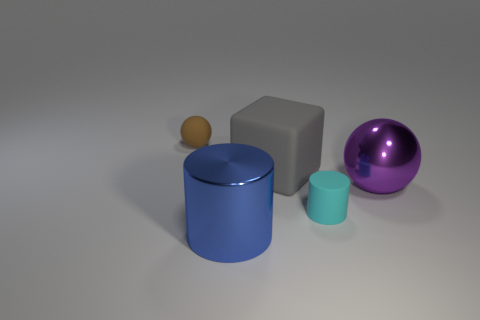Add 3 small blue matte cylinders. How many objects exist? 8 Subtract all blocks. How many objects are left? 4 Add 4 brown cylinders. How many brown cylinders exist? 4 Subtract 0 brown cylinders. How many objects are left? 5 Subtract all cyan objects. Subtract all gray cubes. How many objects are left? 3 Add 3 purple shiny objects. How many purple shiny objects are left? 4 